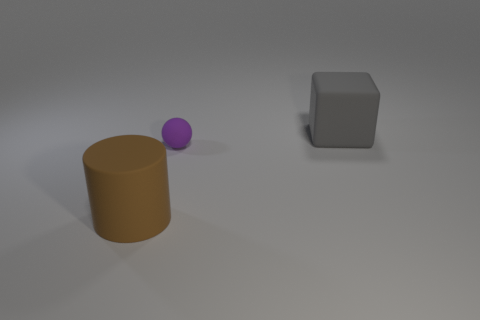Add 2 large blue rubber cylinders. How many objects exist? 5 Subtract all cylinders. How many objects are left? 2 Add 1 green matte cylinders. How many green matte cylinders exist? 1 Subtract 0 red spheres. How many objects are left? 3 Subtract all small rubber objects. Subtract all big cyan matte objects. How many objects are left? 2 Add 1 small purple matte things. How many small purple matte things are left? 2 